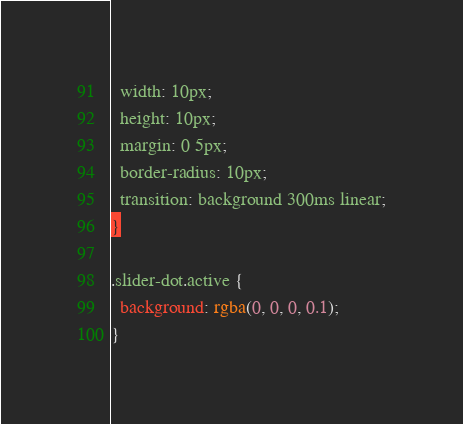Convert code to text. <code><loc_0><loc_0><loc_500><loc_500><_CSS_>  width: 10px;
  height: 10px;
  margin: 0 5px;
  border-radius: 10px;
  transition: background 300ms linear;
}

.slider-dot.active {
  background: rgba(0, 0, 0, 0.1);
}
</code> 